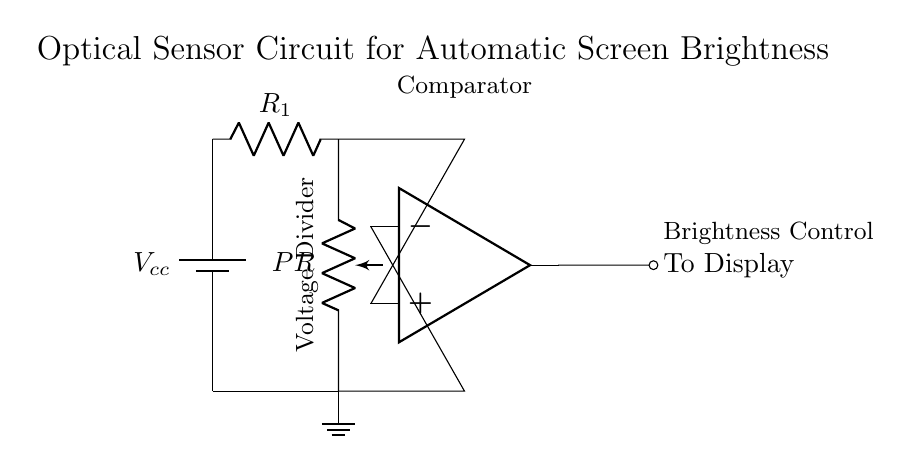What is the type of light-sensitive component in this circuit? The circuit contains a photoresistor, which is specifically designed to change resistance based on light intensity. This is indicated in the diagram by the label 'PR'.
Answer: photoresistor What is the value of the power supply voltage in this circuit? The circuit diagram does not specify an exact numerical value for the voltage, but it indicates a general power supply labeled as 'Vcc'. This suggests that it provides a positive voltage for the operation of the circuit.
Answer: Vcc What are the two inputs to the op-amp in this circuit? The op-amp has two inputs; one is connected to the top point of the photoresistor (which serves as the voltage divider) and the other is connected to the bottom point of the photoresistor (ground). These connections are vital for its function as a comparator.
Answer: voltage divider and ground What role does the resistor R1 play in this circuit? Resistor R1 is part of the voltage divider formed with the photoresistor, which is critical to setting the threshold voltage at the non-inverting input of the op-amp. It allows for adjustment based on the light intensity detected by the photoresistor.
Answer: voltage divider What does the output of the op-amp control in this circuit? The output of the op-amp is directly connected to the display, where it influences the screen brightness based on the comparison of the input voltages, effectively adjusting the brightness according to ambient light levels.
Answer: brightness control What is the purpose of having a ground connection in the circuit? The ground connection serves as a reference point for all voltages in the circuit. It completes the circuit by providing a return path for current, ensuring that the op-amp and other components operate correctly and safely.
Answer: reference point 